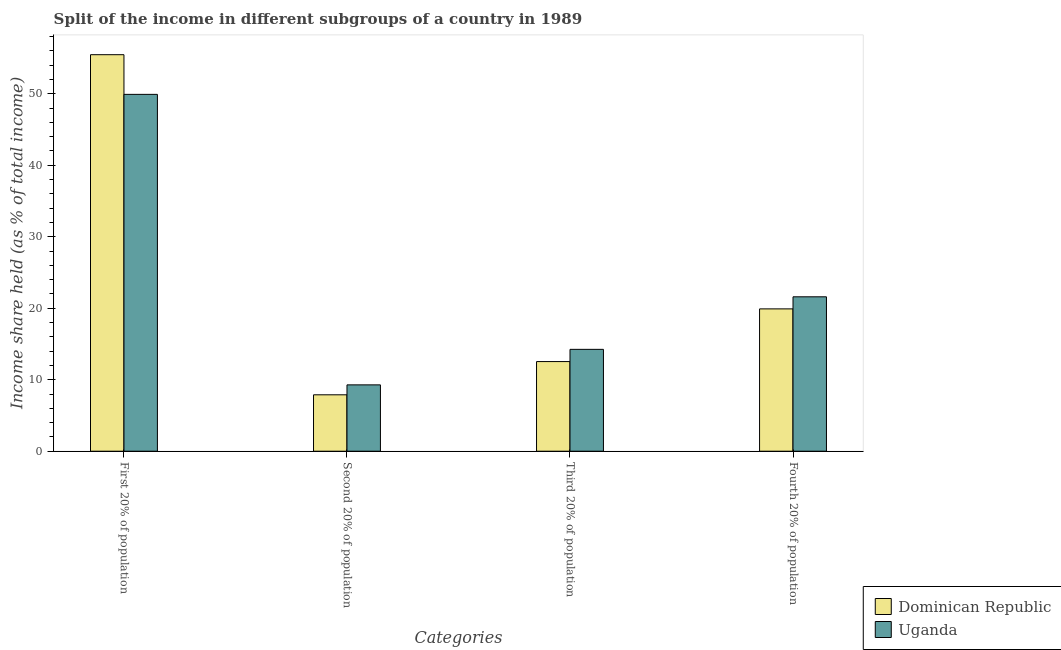How many different coloured bars are there?
Offer a terse response. 2. How many groups of bars are there?
Provide a short and direct response. 4. Are the number of bars per tick equal to the number of legend labels?
Your answer should be compact. Yes. How many bars are there on the 1st tick from the right?
Give a very brief answer. 2. What is the label of the 4th group of bars from the left?
Make the answer very short. Fourth 20% of population. What is the share of the income held by second 20% of the population in Uganda?
Offer a very short reply. 9.28. Across all countries, what is the maximum share of the income held by first 20% of the population?
Your response must be concise. 55.47. Across all countries, what is the minimum share of the income held by fourth 20% of the population?
Give a very brief answer. 19.91. In which country was the share of the income held by fourth 20% of the population maximum?
Your answer should be very brief. Uganda. In which country was the share of the income held by second 20% of the population minimum?
Your answer should be very brief. Dominican Republic. What is the total share of the income held by second 20% of the population in the graph?
Offer a very short reply. 17.17. What is the difference between the share of the income held by first 20% of the population in Uganda and that in Dominican Republic?
Provide a succinct answer. -5.55. What is the difference between the share of the income held by third 20% of the population in Uganda and the share of the income held by second 20% of the population in Dominican Republic?
Offer a terse response. 6.36. What is the average share of the income held by first 20% of the population per country?
Keep it short and to the point. 52.7. What is the difference between the share of the income held by third 20% of the population and share of the income held by fourth 20% of the population in Dominican Republic?
Give a very brief answer. -7.37. In how many countries, is the share of the income held by fourth 20% of the population greater than 54 %?
Provide a short and direct response. 0. What is the ratio of the share of the income held by third 20% of the population in Dominican Republic to that in Uganda?
Your answer should be very brief. 0.88. What is the difference between the highest and the second highest share of the income held by fourth 20% of the population?
Give a very brief answer. 1.69. What is the difference between the highest and the lowest share of the income held by second 20% of the population?
Your response must be concise. 1.39. In how many countries, is the share of the income held by third 20% of the population greater than the average share of the income held by third 20% of the population taken over all countries?
Make the answer very short. 1. What does the 1st bar from the left in Third 20% of population represents?
Give a very brief answer. Dominican Republic. What does the 1st bar from the right in Second 20% of population represents?
Offer a very short reply. Uganda. Are all the bars in the graph horizontal?
Your response must be concise. No. Does the graph contain any zero values?
Provide a succinct answer. No. Where does the legend appear in the graph?
Give a very brief answer. Bottom right. What is the title of the graph?
Keep it short and to the point. Split of the income in different subgroups of a country in 1989. What is the label or title of the X-axis?
Your response must be concise. Categories. What is the label or title of the Y-axis?
Give a very brief answer. Income share held (as % of total income). What is the Income share held (as % of total income) of Dominican Republic in First 20% of population?
Ensure brevity in your answer.  55.47. What is the Income share held (as % of total income) in Uganda in First 20% of population?
Provide a short and direct response. 49.92. What is the Income share held (as % of total income) of Dominican Republic in Second 20% of population?
Offer a very short reply. 7.89. What is the Income share held (as % of total income) of Uganda in Second 20% of population?
Provide a succinct answer. 9.28. What is the Income share held (as % of total income) of Dominican Republic in Third 20% of population?
Keep it short and to the point. 12.54. What is the Income share held (as % of total income) of Uganda in Third 20% of population?
Keep it short and to the point. 14.25. What is the Income share held (as % of total income) in Dominican Republic in Fourth 20% of population?
Provide a succinct answer. 19.91. What is the Income share held (as % of total income) in Uganda in Fourth 20% of population?
Ensure brevity in your answer.  21.6. Across all Categories, what is the maximum Income share held (as % of total income) in Dominican Republic?
Give a very brief answer. 55.47. Across all Categories, what is the maximum Income share held (as % of total income) of Uganda?
Provide a succinct answer. 49.92. Across all Categories, what is the minimum Income share held (as % of total income) in Dominican Republic?
Provide a short and direct response. 7.89. Across all Categories, what is the minimum Income share held (as % of total income) of Uganda?
Offer a very short reply. 9.28. What is the total Income share held (as % of total income) of Dominican Republic in the graph?
Ensure brevity in your answer.  95.81. What is the total Income share held (as % of total income) in Uganda in the graph?
Offer a terse response. 95.05. What is the difference between the Income share held (as % of total income) of Dominican Republic in First 20% of population and that in Second 20% of population?
Your response must be concise. 47.58. What is the difference between the Income share held (as % of total income) of Uganda in First 20% of population and that in Second 20% of population?
Keep it short and to the point. 40.64. What is the difference between the Income share held (as % of total income) in Dominican Republic in First 20% of population and that in Third 20% of population?
Ensure brevity in your answer.  42.93. What is the difference between the Income share held (as % of total income) of Uganda in First 20% of population and that in Third 20% of population?
Your answer should be very brief. 35.67. What is the difference between the Income share held (as % of total income) of Dominican Republic in First 20% of population and that in Fourth 20% of population?
Your answer should be compact. 35.56. What is the difference between the Income share held (as % of total income) in Uganda in First 20% of population and that in Fourth 20% of population?
Make the answer very short. 28.32. What is the difference between the Income share held (as % of total income) in Dominican Republic in Second 20% of population and that in Third 20% of population?
Make the answer very short. -4.65. What is the difference between the Income share held (as % of total income) of Uganda in Second 20% of population and that in Third 20% of population?
Provide a succinct answer. -4.97. What is the difference between the Income share held (as % of total income) of Dominican Republic in Second 20% of population and that in Fourth 20% of population?
Give a very brief answer. -12.02. What is the difference between the Income share held (as % of total income) of Uganda in Second 20% of population and that in Fourth 20% of population?
Offer a very short reply. -12.32. What is the difference between the Income share held (as % of total income) in Dominican Republic in Third 20% of population and that in Fourth 20% of population?
Your answer should be very brief. -7.37. What is the difference between the Income share held (as % of total income) of Uganda in Third 20% of population and that in Fourth 20% of population?
Your answer should be compact. -7.35. What is the difference between the Income share held (as % of total income) in Dominican Republic in First 20% of population and the Income share held (as % of total income) in Uganda in Second 20% of population?
Provide a succinct answer. 46.19. What is the difference between the Income share held (as % of total income) of Dominican Republic in First 20% of population and the Income share held (as % of total income) of Uganda in Third 20% of population?
Keep it short and to the point. 41.22. What is the difference between the Income share held (as % of total income) in Dominican Republic in First 20% of population and the Income share held (as % of total income) in Uganda in Fourth 20% of population?
Keep it short and to the point. 33.87. What is the difference between the Income share held (as % of total income) in Dominican Republic in Second 20% of population and the Income share held (as % of total income) in Uganda in Third 20% of population?
Offer a terse response. -6.36. What is the difference between the Income share held (as % of total income) of Dominican Republic in Second 20% of population and the Income share held (as % of total income) of Uganda in Fourth 20% of population?
Provide a short and direct response. -13.71. What is the difference between the Income share held (as % of total income) in Dominican Republic in Third 20% of population and the Income share held (as % of total income) in Uganda in Fourth 20% of population?
Your answer should be very brief. -9.06. What is the average Income share held (as % of total income) of Dominican Republic per Categories?
Make the answer very short. 23.95. What is the average Income share held (as % of total income) in Uganda per Categories?
Provide a short and direct response. 23.76. What is the difference between the Income share held (as % of total income) of Dominican Republic and Income share held (as % of total income) of Uganda in First 20% of population?
Provide a succinct answer. 5.55. What is the difference between the Income share held (as % of total income) of Dominican Republic and Income share held (as % of total income) of Uganda in Second 20% of population?
Give a very brief answer. -1.39. What is the difference between the Income share held (as % of total income) in Dominican Republic and Income share held (as % of total income) in Uganda in Third 20% of population?
Offer a very short reply. -1.71. What is the difference between the Income share held (as % of total income) of Dominican Republic and Income share held (as % of total income) of Uganda in Fourth 20% of population?
Give a very brief answer. -1.69. What is the ratio of the Income share held (as % of total income) of Dominican Republic in First 20% of population to that in Second 20% of population?
Keep it short and to the point. 7.03. What is the ratio of the Income share held (as % of total income) of Uganda in First 20% of population to that in Second 20% of population?
Provide a short and direct response. 5.38. What is the ratio of the Income share held (as % of total income) of Dominican Republic in First 20% of population to that in Third 20% of population?
Your answer should be very brief. 4.42. What is the ratio of the Income share held (as % of total income) of Uganda in First 20% of population to that in Third 20% of population?
Offer a very short reply. 3.5. What is the ratio of the Income share held (as % of total income) of Dominican Republic in First 20% of population to that in Fourth 20% of population?
Make the answer very short. 2.79. What is the ratio of the Income share held (as % of total income) of Uganda in First 20% of population to that in Fourth 20% of population?
Keep it short and to the point. 2.31. What is the ratio of the Income share held (as % of total income) of Dominican Republic in Second 20% of population to that in Third 20% of population?
Ensure brevity in your answer.  0.63. What is the ratio of the Income share held (as % of total income) in Uganda in Second 20% of population to that in Third 20% of population?
Your answer should be very brief. 0.65. What is the ratio of the Income share held (as % of total income) of Dominican Republic in Second 20% of population to that in Fourth 20% of population?
Your answer should be very brief. 0.4. What is the ratio of the Income share held (as % of total income) of Uganda in Second 20% of population to that in Fourth 20% of population?
Offer a very short reply. 0.43. What is the ratio of the Income share held (as % of total income) of Dominican Republic in Third 20% of population to that in Fourth 20% of population?
Provide a succinct answer. 0.63. What is the ratio of the Income share held (as % of total income) of Uganda in Third 20% of population to that in Fourth 20% of population?
Keep it short and to the point. 0.66. What is the difference between the highest and the second highest Income share held (as % of total income) in Dominican Republic?
Provide a short and direct response. 35.56. What is the difference between the highest and the second highest Income share held (as % of total income) of Uganda?
Give a very brief answer. 28.32. What is the difference between the highest and the lowest Income share held (as % of total income) of Dominican Republic?
Provide a short and direct response. 47.58. What is the difference between the highest and the lowest Income share held (as % of total income) in Uganda?
Provide a short and direct response. 40.64. 